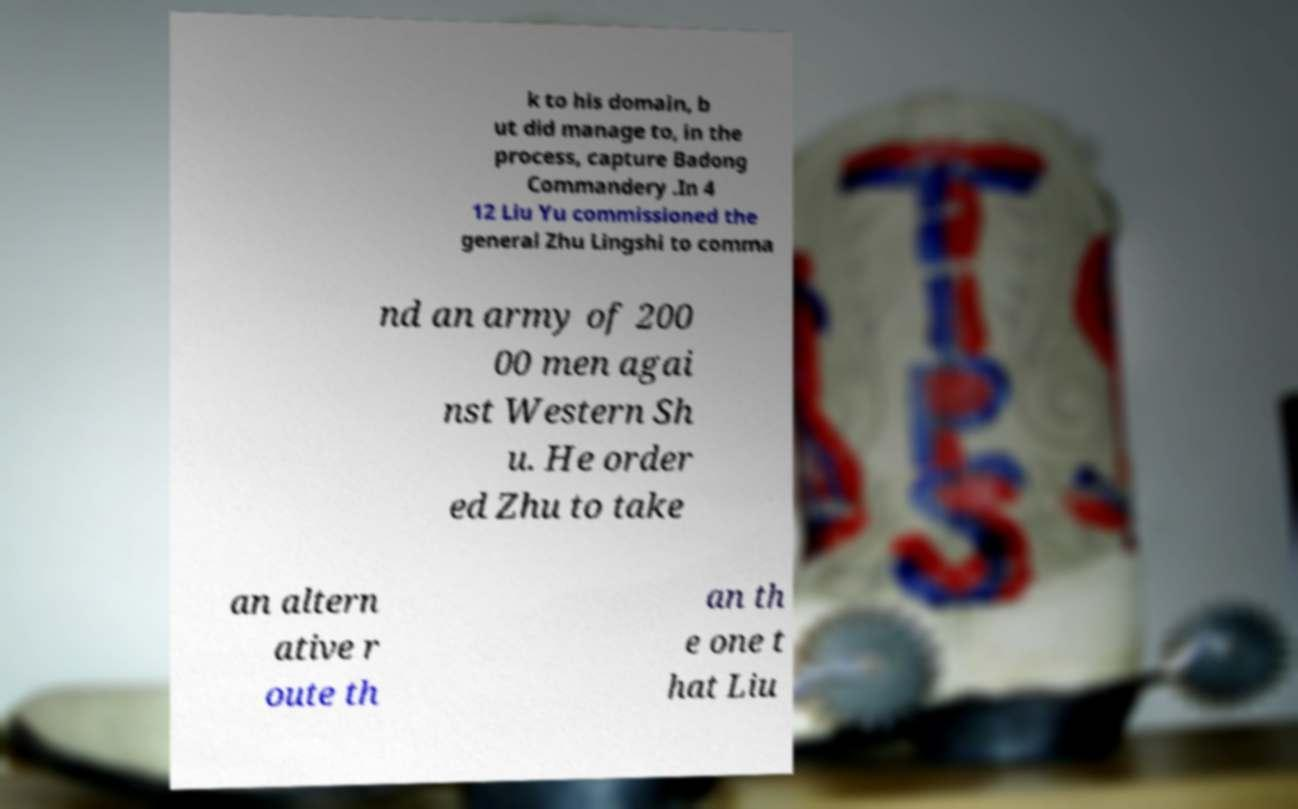I need the written content from this picture converted into text. Can you do that? k to his domain, b ut did manage to, in the process, capture Badong Commandery .In 4 12 Liu Yu commissioned the general Zhu Lingshi to comma nd an army of 200 00 men agai nst Western Sh u. He order ed Zhu to take an altern ative r oute th an th e one t hat Liu 